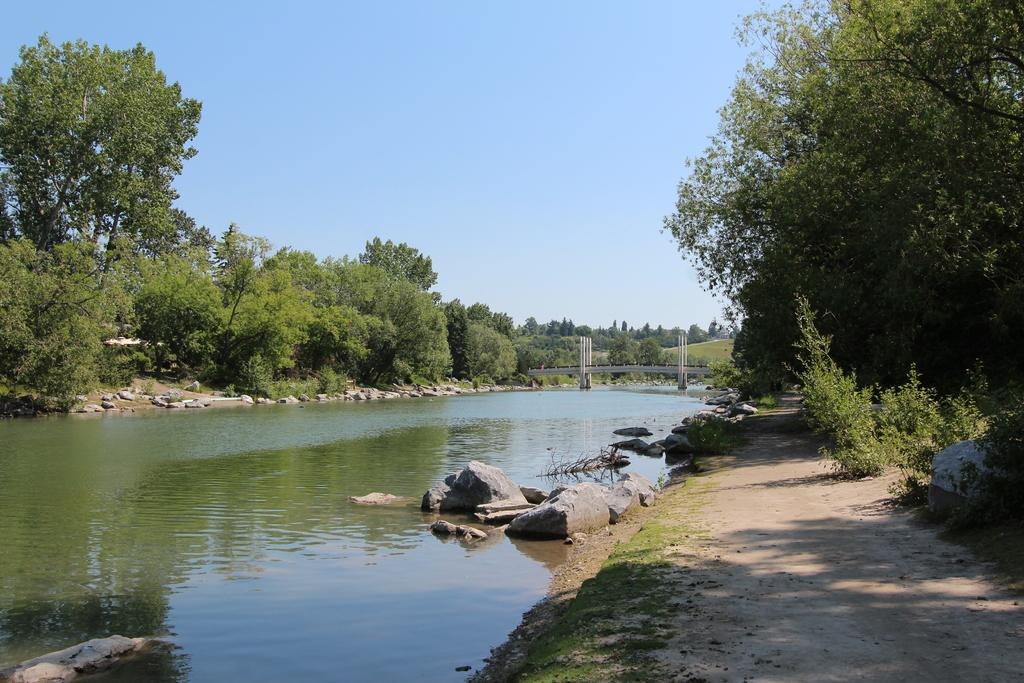What is the primary element present in the image? There is water in the image. What other objects or features can be seen in the image? There are rocks and trees visible in the image. Can you describe the background of the image? There is a bridge visible in the background of the image. How many zebras can be seen swimming in the water in the image? There are no zebras present in the image. What type of bubble is floating near the rocks in the image? There are no bubbles present in the image. 